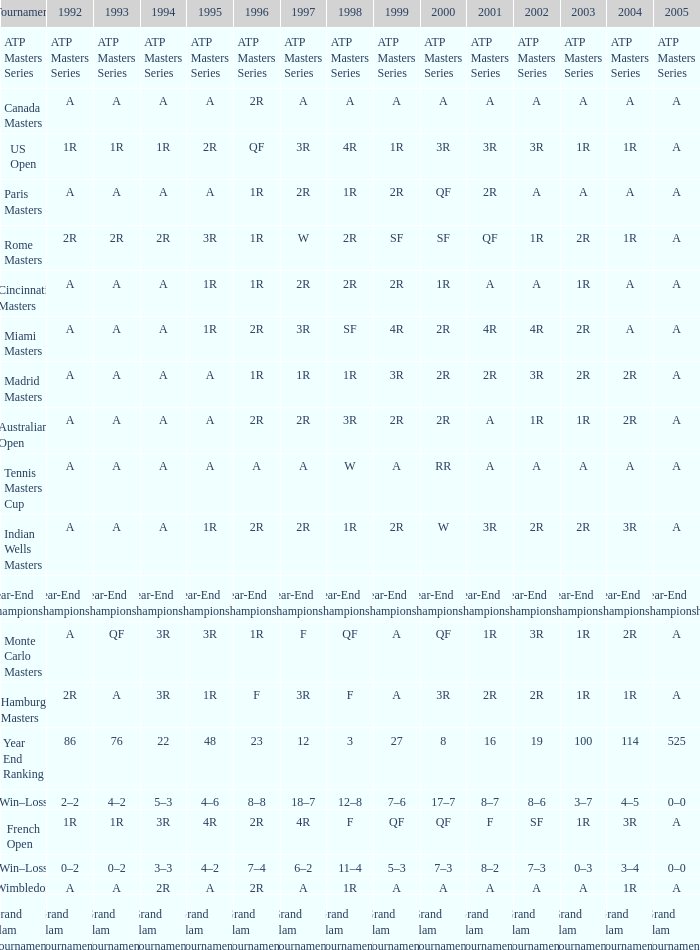What is 1998, when 1997 is "3R", and when 1992 is "A"? SF. 